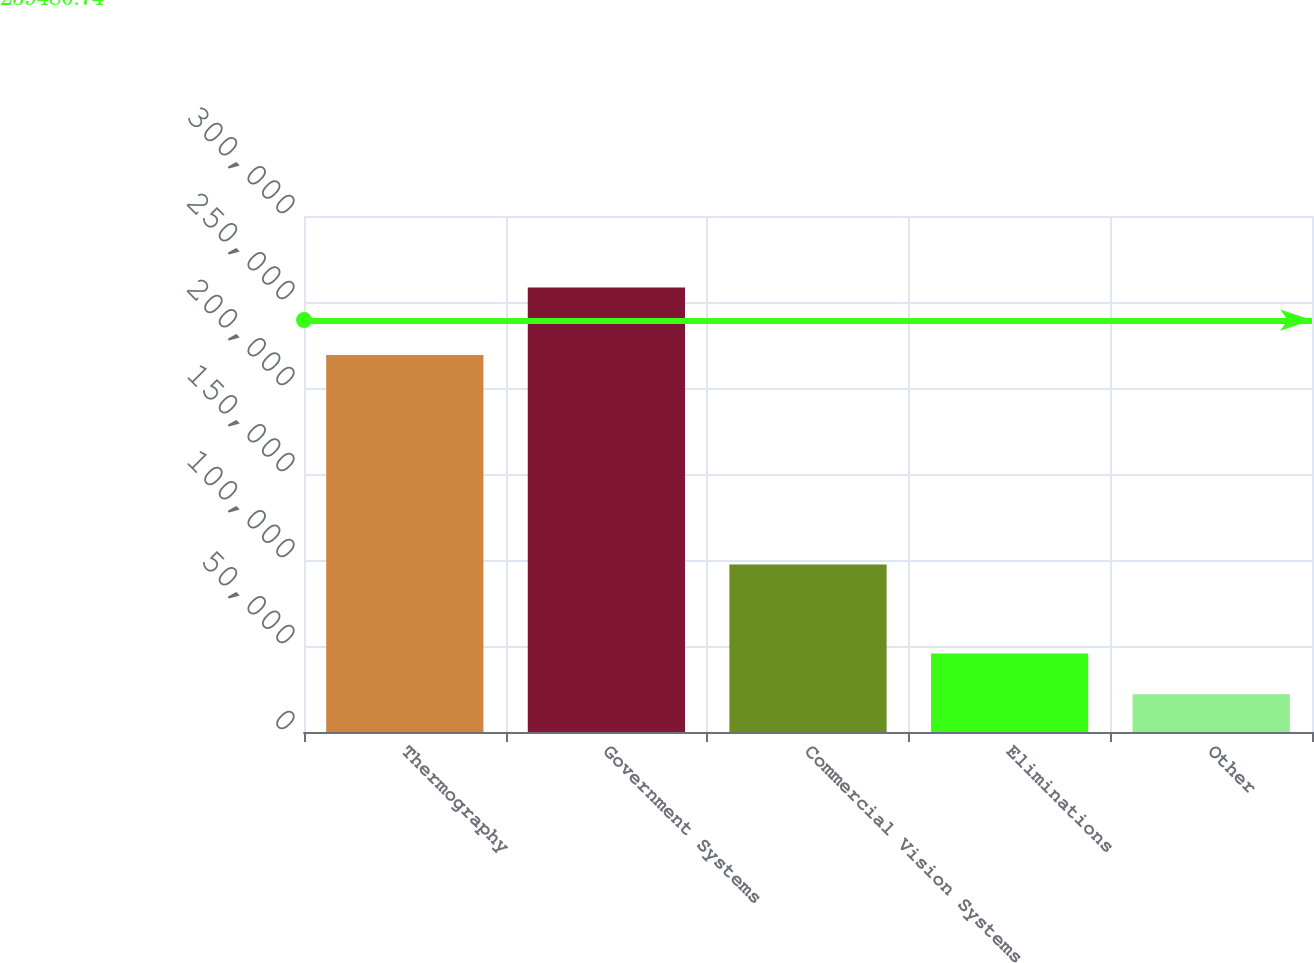<chart> <loc_0><loc_0><loc_500><loc_500><bar_chart><fcel>Thermography<fcel>Government Systems<fcel>Commercial Vision Systems<fcel>Eliminations<fcel>Other<nl><fcel>219218<fcel>258436<fcel>97346<fcel>45590.5<fcel>21941<nl></chart> 